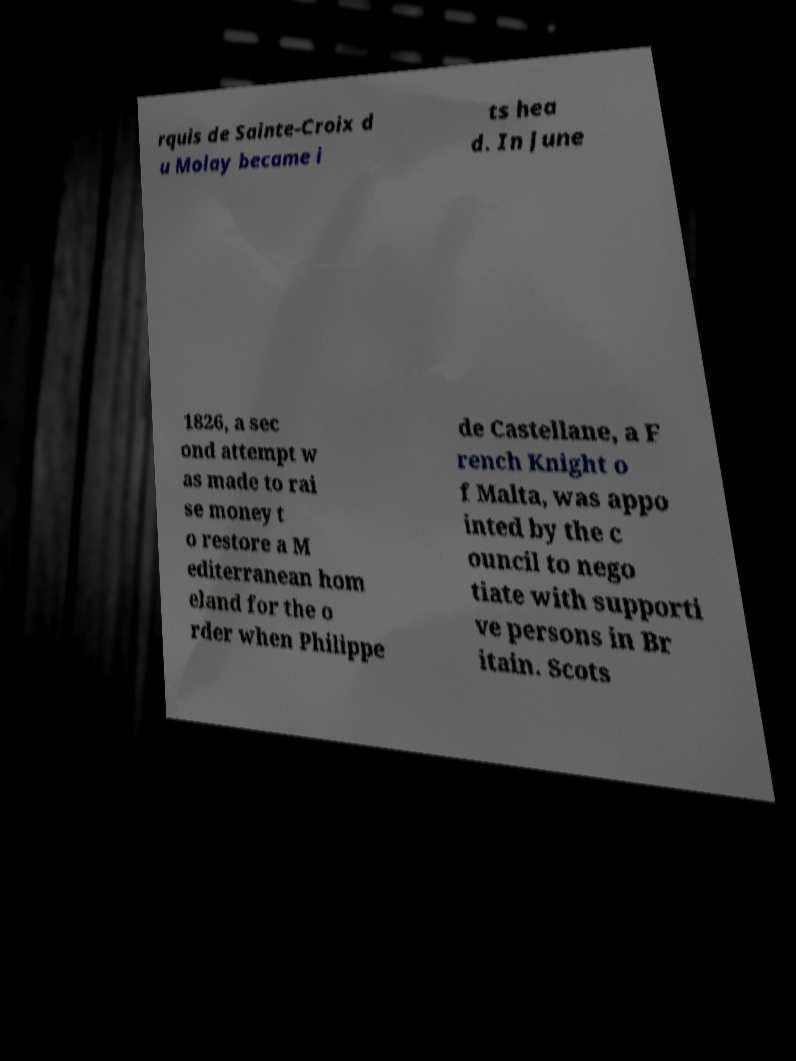Can you accurately transcribe the text from the provided image for me? rquis de Sainte-Croix d u Molay became i ts hea d. In June 1826, a sec ond attempt w as made to rai se money t o restore a M editerranean hom eland for the o rder when Philippe de Castellane, a F rench Knight o f Malta, was appo inted by the c ouncil to nego tiate with supporti ve persons in Br itain. Scots 